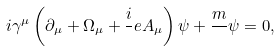Convert formula to latex. <formula><loc_0><loc_0><loc_500><loc_500>i \gamma ^ { \mu } \left ( { \partial _ { \mu } + \Omega _ { \mu } + \frac { i } { } e A _ { \mu } } \right ) \psi + \frac { m } { } \psi = 0 ,</formula> 